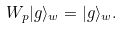Convert formula to latex. <formula><loc_0><loc_0><loc_500><loc_500>W _ { p } | g \rangle _ { w } = | g \rangle _ { w } .</formula> 